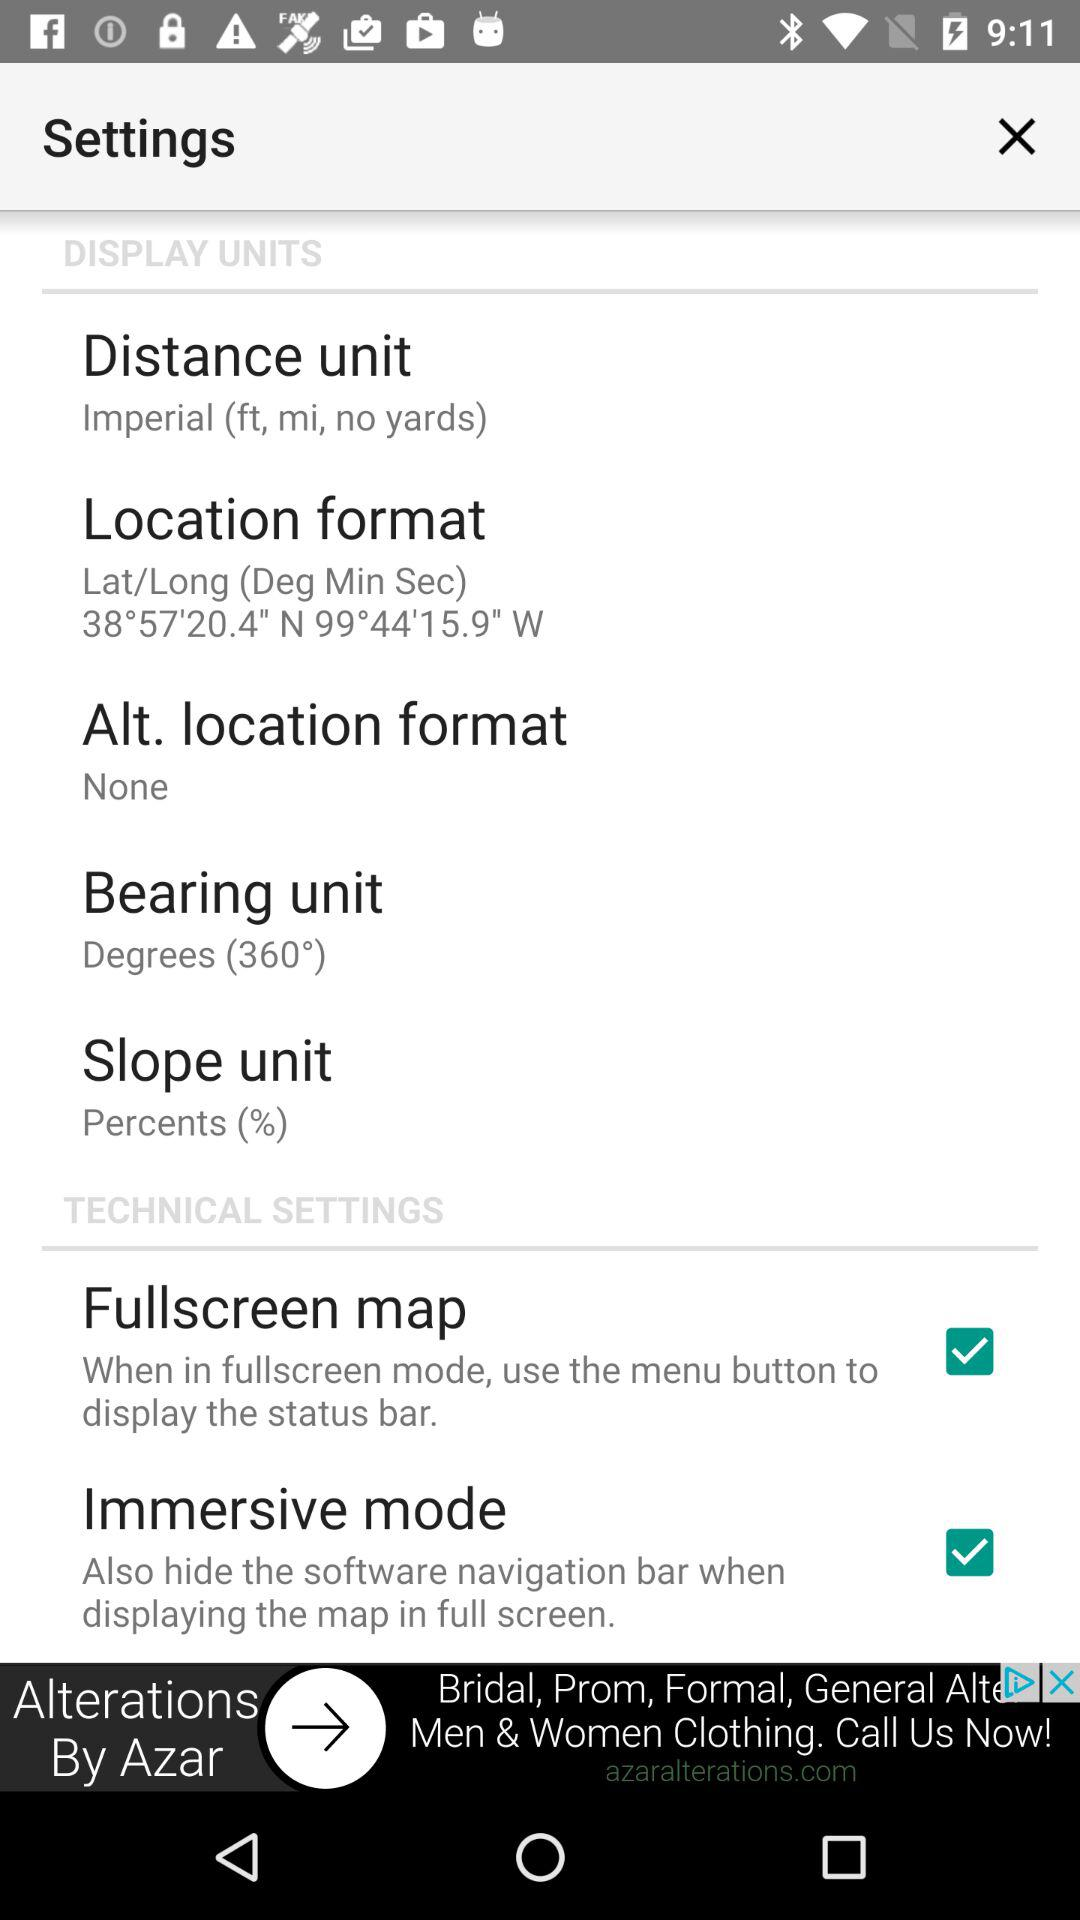How many checkbox are there in the technical settings section?
Answer the question using a single word or phrase. 2 